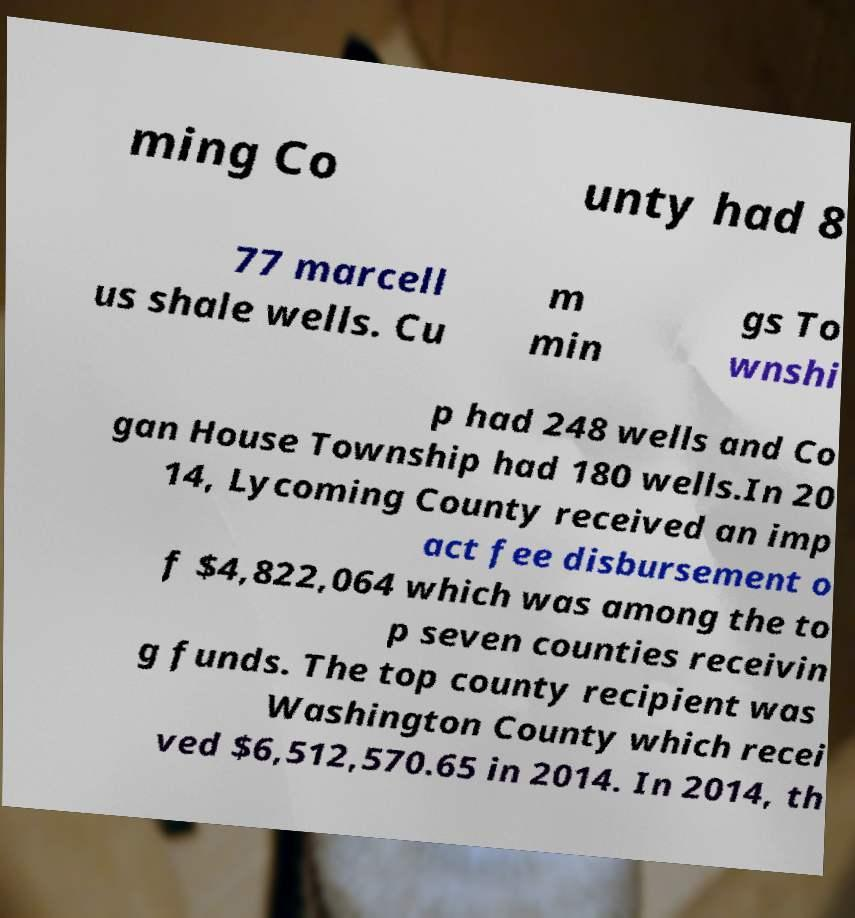There's text embedded in this image that I need extracted. Can you transcribe it verbatim? ming Co unty had 8 77 marcell us shale wells. Cu m min gs To wnshi p had 248 wells and Co gan House Township had 180 wells.In 20 14, Lycoming County received an imp act fee disbursement o f $4,822,064 which was among the to p seven counties receivin g funds. The top county recipient was Washington County which recei ved $6,512,570.65 in 2014. In 2014, th 